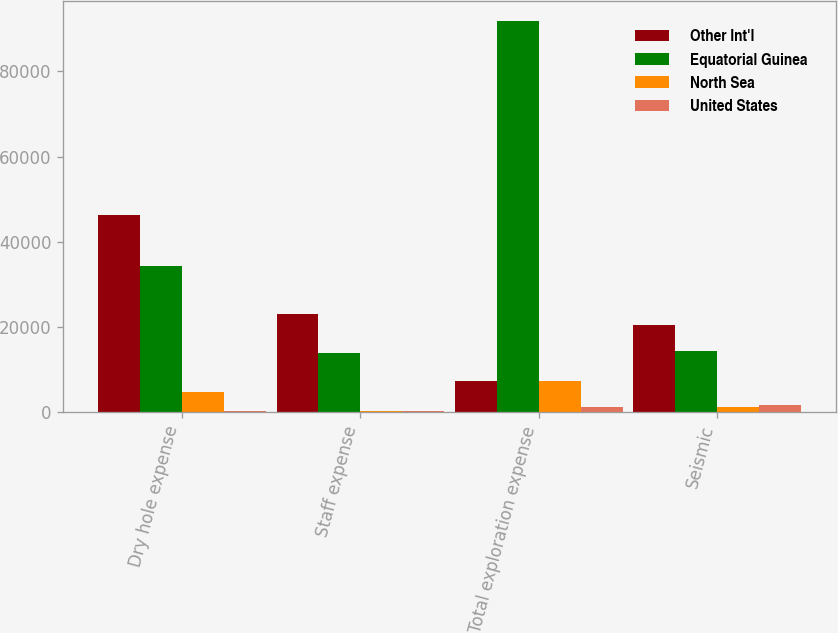Convert chart. <chart><loc_0><loc_0><loc_500><loc_500><stacked_bar_chart><ecel><fcel>Dry hole expense<fcel>Staff expense<fcel>Total exploration expense<fcel>Seismic<nl><fcel>Other Int'l<fcel>46192<fcel>22990<fcel>7214<fcel>20492<nl><fcel>Equatorial Guinea<fcel>34236<fcel>13926<fcel>91892<fcel>14282<nl><fcel>North Sea<fcel>4676<fcel>260<fcel>7214<fcel>1341<nl><fcel>United States<fcel>293<fcel>305<fcel>1123<fcel>1671<nl></chart> 